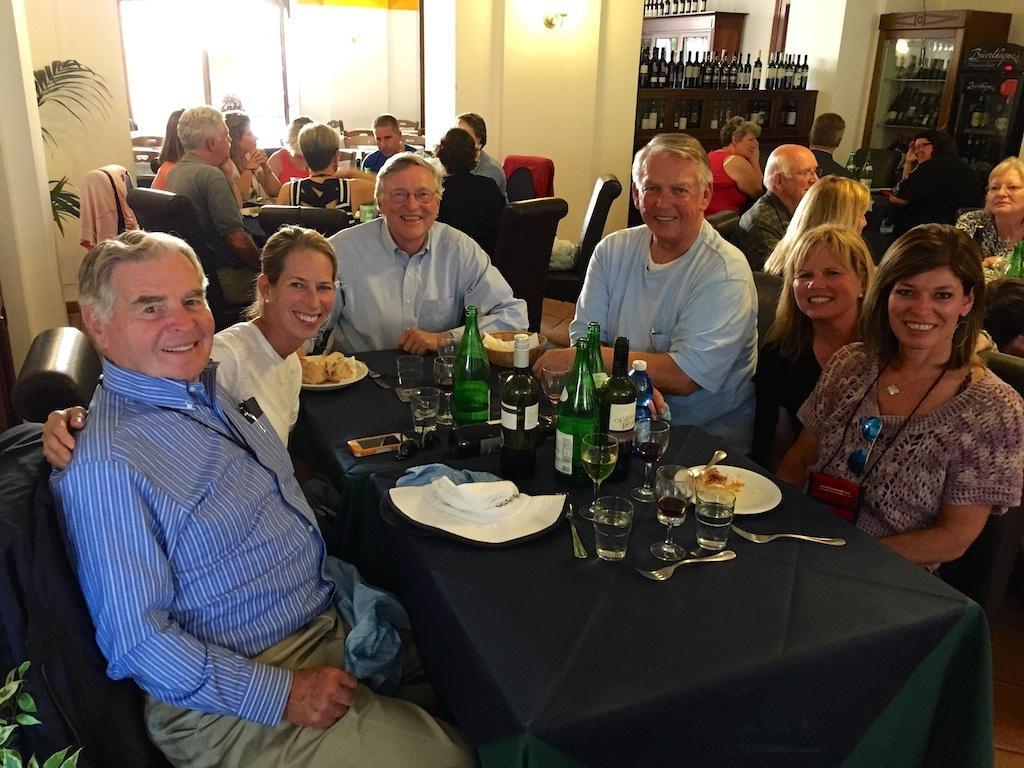Please provide a concise description of this image. This picture is clicked inside a restaurant. There are many people sitting on the chair. In front of this picture, we see a table which is covered with green color cloth. On table, we see glass, fork, plate, spoon, wine bottle and mobile phone. On background, we have a wall and a window. On the right top of this picture, we find a cupboard in which many wine bottles are placed. 